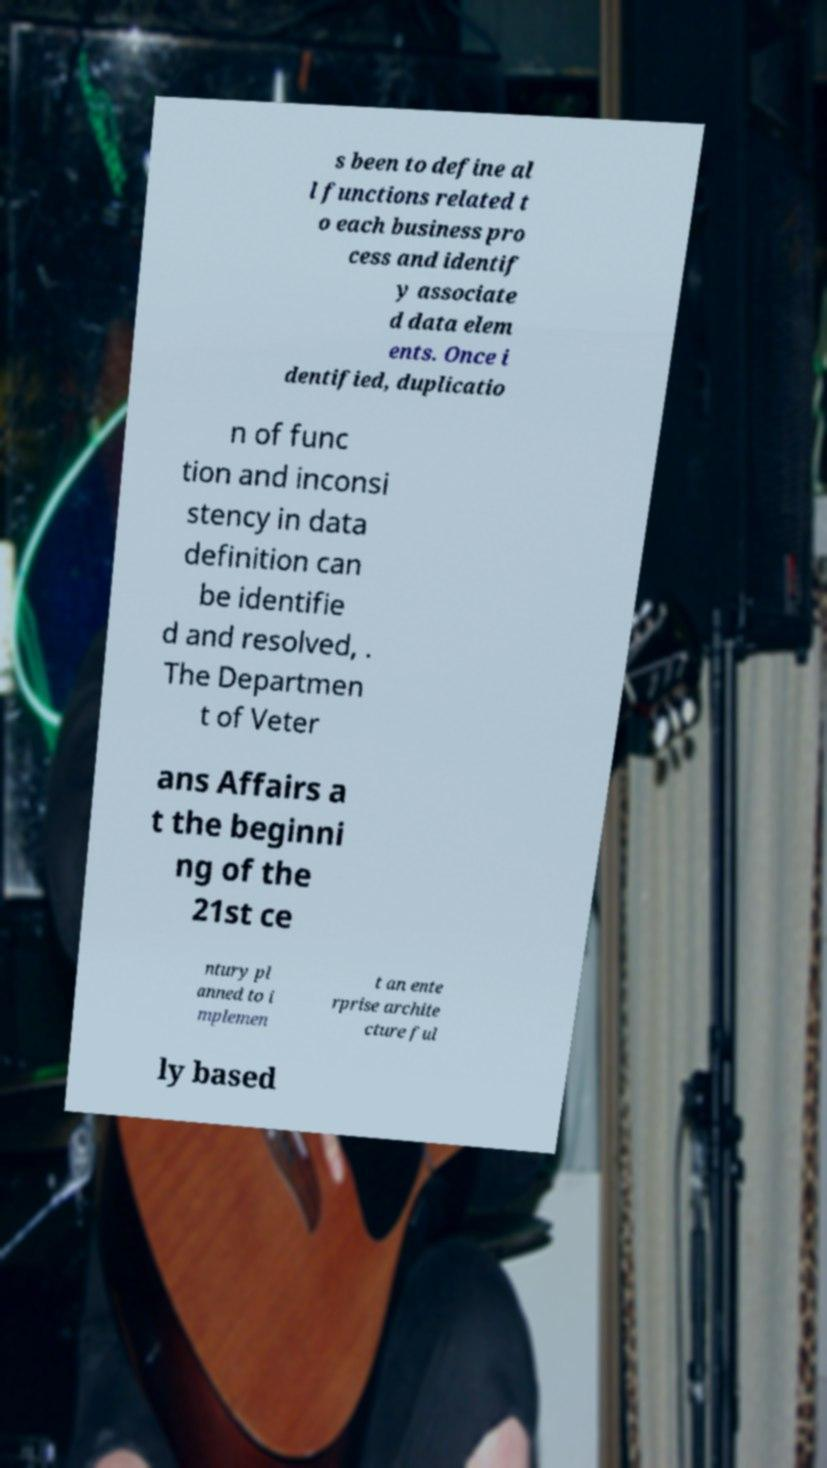Please identify and transcribe the text found in this image. s been to define al l functions related t o each business pro cess and identif y associate d data elem ents. Once i dentified, duplicatio n of func tion and inconsi stency in data definition can be identifie d and resolved, . The Departmen t of Veter ans Affairs a t the beginni ng of the 21st ce ntury pl anned to i mplemen t an ente rprise archite cture ful ly based 